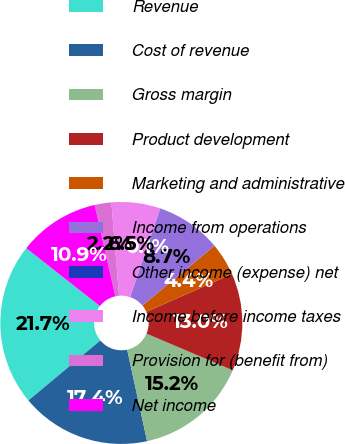Convert chart to OTSL. <chart><loc_0><loc_0><loc_500><loc_500><pie_chart><fcel>Revenue<fcel>Cost of revenue<fcel>Gross margin<fcel>Product development<fcel>Marketing and administrative<fcel>Income from operations<fcel>Other income (expense) net<fcel>Income before income taxes<fcel>Provision for (benefit from)<fcel>Net income<nl><fcel>21.67%<fcel>17.35%<fcel>15.19%<fcel>13.03%<fcel>4.38%<fcel>8.7%<fcel>0.06%<fcel>6.54%<fcel>2.22%<fcel>10.86%<nl></chart> 